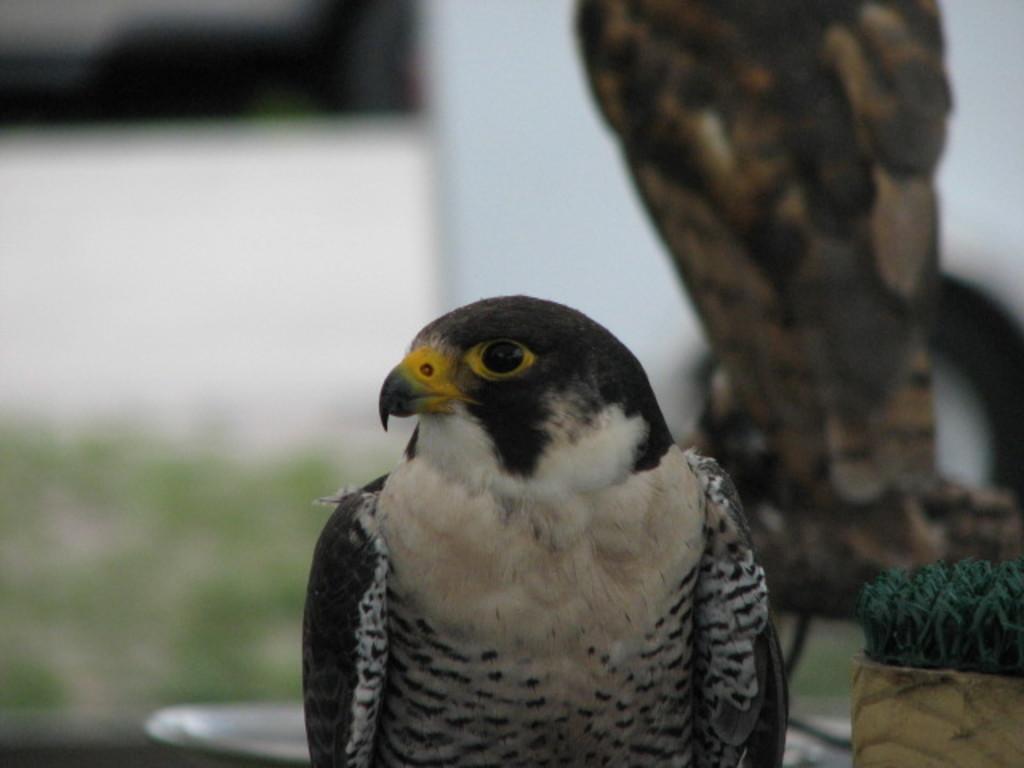In one or two sentences, can you explain what this image depicts? In the image we can see the bird, white, black and yellow in color, and the background is blurred. 